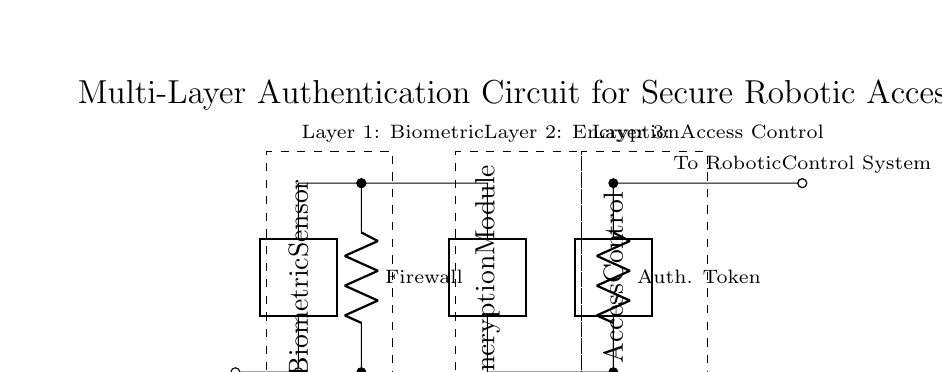What is the first layer of authentication in the circuit? The first layer of authentication is indicated by the dashed rectangle at the left, which contains the Biometric Sensor component. This is the initial step in the multi-layer authentication process for access control.
Answer: Biometric What component follows the Biometric Sensor in the circuit? The component that directly follows the Biometric Sensor is the Firewall, which is represented as a resistor in the circuit diagram. This shows that it is part of the security layer following the biometric verification.
Answer: Firewall How many layers of authentication are present in the circuit? The circuit showcases three distinct layers of authentication, as seen in the three dashed rectangles, each labeled accordingly. This designates that there are multiple processes involved before granting access to the robotic control.
Answer: Three What type of module is shown at the second layer? The component at the second layer, indicated by the dashed rectangle, is labeled as the Encryption Module. This suggests that encryption plays a vital role in securing information within the circuit, enhancing the overall security framework.
Answer: Encryption Module What is the purpose of the Authentication Token component? The Authentication Token serves as a verification mechanism for the third layer, intended to ensure that only authorized entities can gain access to the control system, reinforcing security protocols.
Answer: Verification What does the User Input node represent in the circuit? The User Input node represents the initial entry point where the user provides credentials or biometric data for authentication. This marks the beginning of the multi-layer authentication process.
Answer: Initial Entry Point 